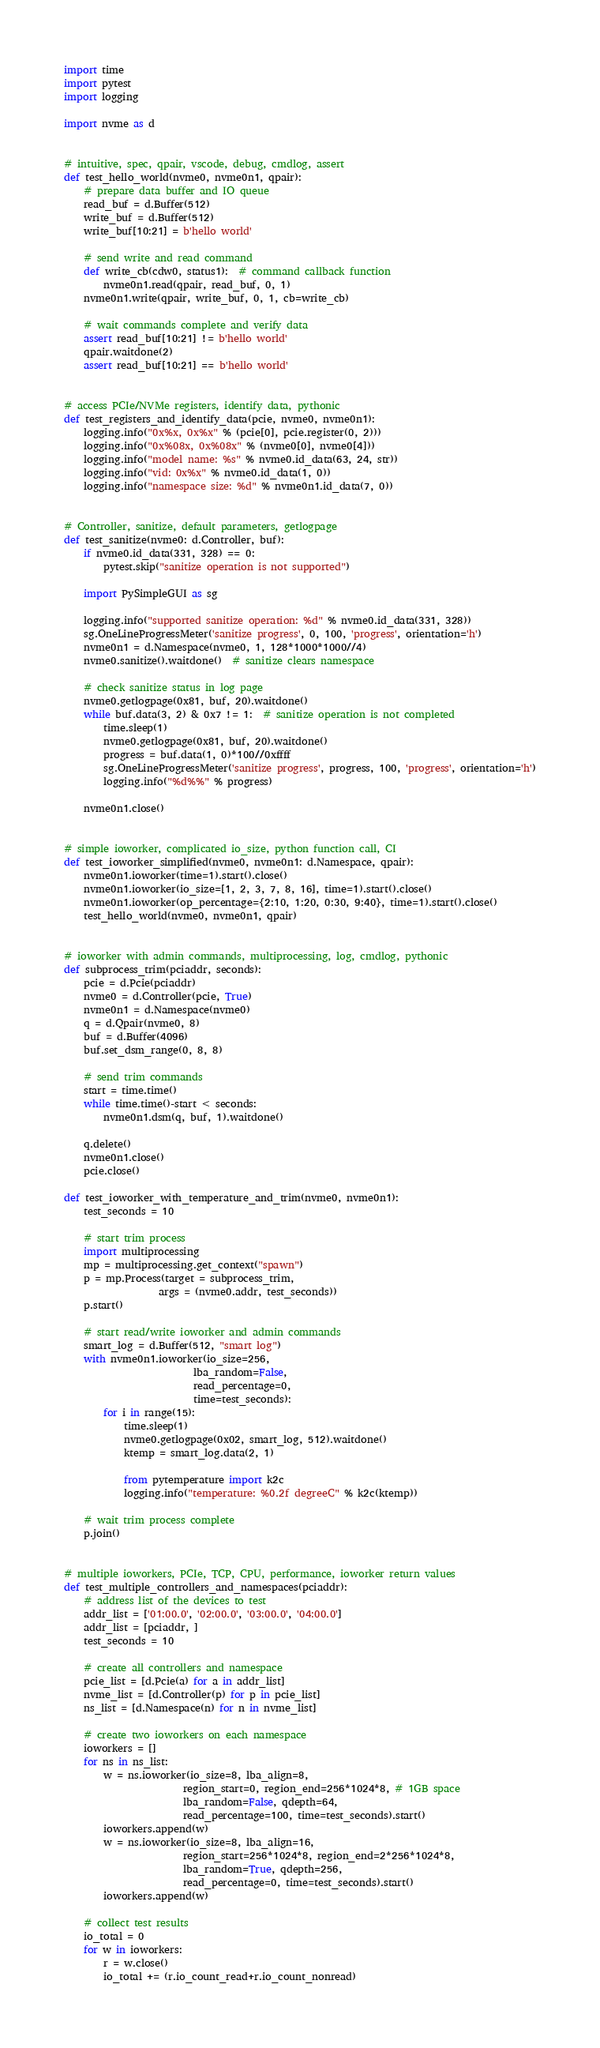<code> <loc_0><loc_0><loc_500><loc_500><_Python_>import time
import pytest
import logging

import nvme as d


# intuitive, spec, qpair, vscode, debug, cmdlog, assert
def test_hello_world(nvme0, nvme0n1, qpair):
    # prepare data buffer and IO queue
    read_buf = d.Buffer(512)
    write_buf = d.Buffer(512)
    write_buf[10:21] = b'hello world'

    # send write and read command
    def write_cb(cdw0, status1):  # command callback function
        nvme0n1.read(qpair, read_buf, 0, 1)
    nvme0n1.write(qpair, write_buf, 0, 1, cb=write_cb)

    # wait commands complete and verify data
    assert read_buf[10:21] != b'hello world'
    qpair.waitdone(2)
    assert read_buf[10:21] == b'hello world'


# access PCIe/NVMe registers, identify data, pythonic
def test_registers_and_identify_data(pcie, nvme0, nvme0n1):
    logging.info("0x%x, 0x%x" % (pcie[0], pcie.register(0, 2)))
    logging.info("0x%08x, 0x%08x" % (nvme0[0], nvme0[4]))
    logging.info("model name: %s" % nvme0.id_data(63, 24, str))
    logging.info("vid: 0x%x" % nvme0.id_data(1, 0))
    logging.info("namespace size: %d" % nvme0n1.id_data(7, 0))


# Controller, sanitize, default parameters, getlogpage
def test_sanitize(nvme0: d.Controller, buf):
    if nvme0.id_data(331, 328) == 0:
        pytest.skip("sanitize operation is not supported")

    import PySimpleGUI as sg

    logging.info("supported sanitize operation: %d" % nvme0.id_data(331, 328))
    sg.OneLineProgressMeter('sanitize progress', 0, 100, 'progress', orientation='h')
    nvme0n1 = d.Namespace(nvme0, 1, 128*1000*1000//4)
    nvme0.sanitize().waitdone()  # sanitize clears namespace

    # check sanitize status in log page
    nvme0.getlogpage(0x81, buf, 20).waitdone()
    while buf.data(3, 2) & 0x7 != 1:  # sanitize operation is not completed
        time.sleep(1)
        nvme0.getlogpage(0x81, buf, 20).waitdone()
        progress = buf.data(1, 0)*100//0xffff
        sg.OneLineProgressMeter('sanitize progress', progress, 100, 'progress', orientation='h')
        logging.info("%d%%" % progress)

    nvme0n1.close()


# simple ioworker, complicated io_size, python function call, CI
def test_ioworker_simplified(nvme0, nvme0n1: d.Namespace, qpair):
    nvme0n1.ioworker(time=1).start().close()
    nvme0n1.ioworker(io_size=[1, 2, 3, 7, 8, 16], time=1).start().close()
    nvme0n1.ioworker(op_percentage={2:10, 1:20, 0:30, 9:40}, time=1).start().close()
    test_hello_world(nvme0, nvme0n1, qpair)


# ioworker with admin commands, multiprocessing, log, cmdlog, pythonic
def subprocess_trim(pciaddr, seconds):
    pcie = d.Pcie(pciaddr)
    nvme0 = d.Controller(pcie, True)
    nvme0n1 = d.Namespace(nvme0)
    q = d.Qpair(nvme0, 8)
    buf = d.Buffer(4096)
    buf.set_dsm_range(0, 8, 8)

    # send trim commands
    start = time.time()
    while time.time()-start < seconds:
        nvme0n1.dsm(q, buf, 1).waitdone()

    q.delete()
    nvme0n1.close()
    pcie.close()

def test_ioworker_with_temperature_and_trim(nvme0, nvme0n1):
    test_seconds = 10

    # start trim process
    import multiprocessing
    mp = multiprocessing.get_context("spawn")
    p = mp.Process(target = subprocess_trim,
                   args = (nvme0.addr, test_seconds))
    p.start()

    # start read/write ioworker and admin commands
    smart_log = d.Buffer(512, "smart log")
    with nvme0n1.ioworker(io_size=256,
                          lba_random=False,
                          read_percentage=0,
                          time=test_seconds):
        for i in range(15):
            time.sleep(1)
            nvme0.getlogpage(0x02, smart_log, 512).waitdone()
            ktemp = smart_log.data(2, 1)

            from pytemperature import k2c
            logging.info("temperature: %0.2f degreeC" % k2c(ktemp))

    # wait trim process complete
    p.join()


# multiple ioworkers, PCIe, TCP, CPU, performance, ioworker return values
def test_multiple_controllers_and_namespaces(pciaddr):
    # address list of the devices to test
    addr_list = ['01:00.0', '02:00.0', '03:00.0', '04:00.0']
    addr_list = [pciaddr, ]
    test_seconds = 10

    # create all controllers and namespace
    pcie_list = [d.Pcie(a) for a in addr_list]
    nvme_list = [d.Controller(p) for p in pcie_list]
    ns_list = [d.Namespace(n) for n in nvme_list]

    # create two ioworkers on each namespace
    ioworkers = []
    for ns in ns_list:
        w = ns.ioworker(io_size=8, lba_align=8,
                        region_start=0, region_end=256*1024*8, # 1GB space
                        lba_random=False, qdepth=64,
                        read_percentage=100, time=test_seconds).start()
        ioworkers.append(w)
        w = ns.ioworker(io_size=8, lba_align=16,
                        region_start=256*1024*8, region_end=2*256*1024*8,
                        lba_random=True, qdepth=256,
                        read_percentage=0, time=test_seconds).start()
        ioworkers.append(w)

    # collect test results
    io_total = 0
    for w in ioworkers:
        r = w.close()
        io_total += (r.io_count_read+r.io_count_nonread)</code> 